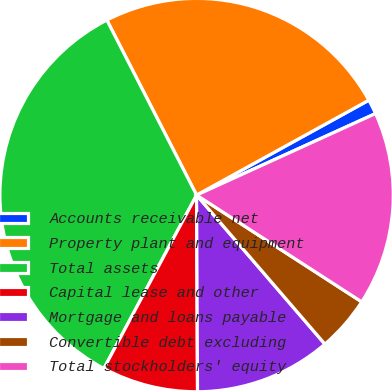<chart> <loc_0><loc_0><loc_500><loc_500><pie_chart><fcel>Accounts receivable net<fcel>Property plant and equipment<fcel>Total assets<fcel>Capital lease and other<fcel>Mortgage and loans payable<fcel>Convertible debt excluding<fcel>Total stockholders' equity<nl><fcel>1.21%<fcel>24.53%<fcel>34.65%<fcel>7.89%<fcel>11.24%<fcel>4.55%<fcel>15.94%<nl></chart> 